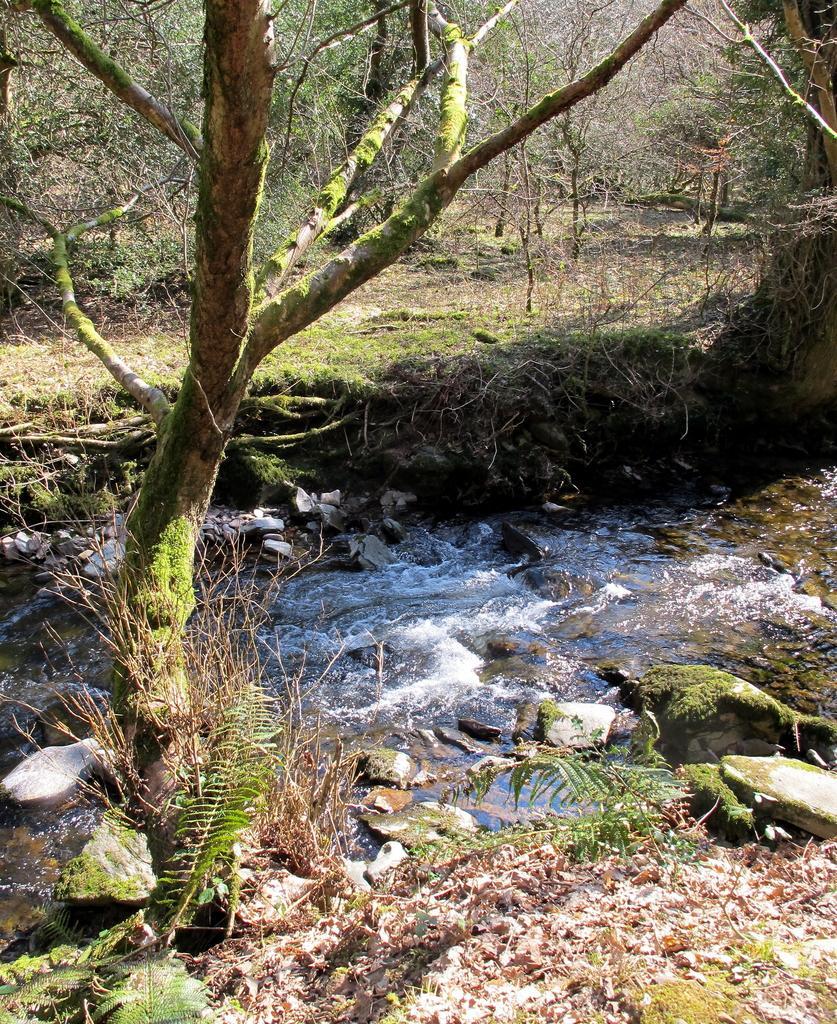Describe this image in one or two sentences. In this image I can see trees in green color, in front I can see water and few rocks. 